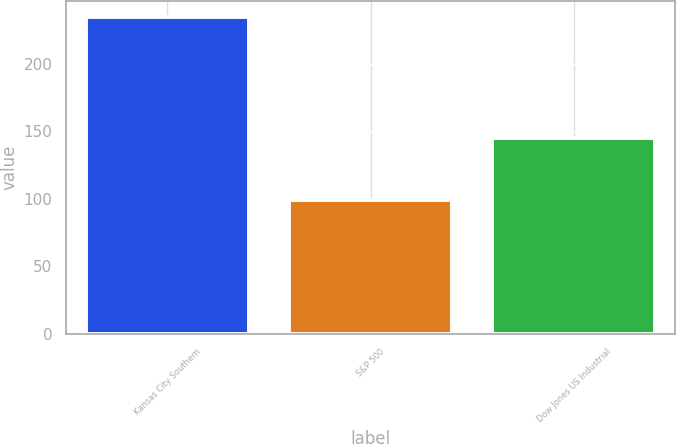Convert chart to OTSL. <chart><loc_0><loc_0><loc_500><loc_500><bar_chart><fcel>Kansas City Southern<fcel>S&P 500<fcel>Dow Jones US Industrial<nl><fcel>234.68<fcel>98.75<fcel>144.83<nl></chart> 